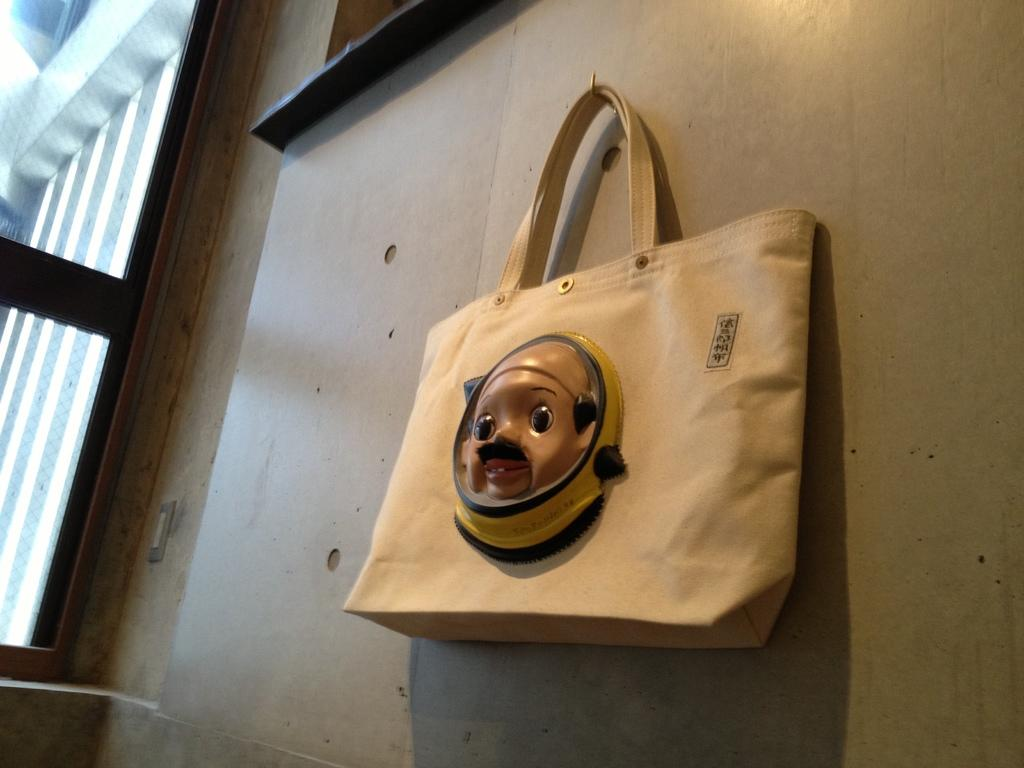What is hanging on the wall in the image? There is a bag hanging on the wall in the image. What else can be seen in the image besides the bag? There is a door visible in the image. How many gloves are lying on the floor near the door in the image? There are no gloves present in the image. What type of cattle can be seen grazing in the background of the image? There is no background or cattle visible in the image; it only features a bag hanging on the wall and a door. 